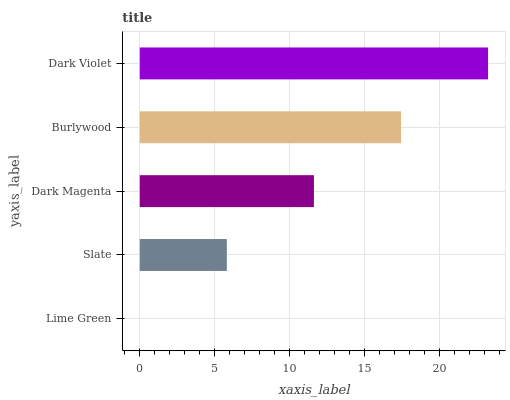Is Lime Green the minimum?
Answer yes or no. Yes. Is Dark Violet the maximum?
Answer yes or no. Yes. Is Slate the minimum?
Answer yes or no. No. Is Slate the maximum?
Answer yes or no. No. Is Slate greater than Lime Green?
Answer yes or no. Yes. Is Lime Green less than Slate?
Answer yes or no. Yes. Is Lime Green greater than Slate?
Answer yes or no. No. Is Slate less than Lime Green?
Answer yes or no. No. Is Dark Magenta the high median?
Answer yes or no. Yes. Is Dark Magenta the low median?
Answer yes or no. Yes. Is Burlywood the high median?
Answer yes or no. No. Is Dark Violet the low median?
Answer yes or no. No. 